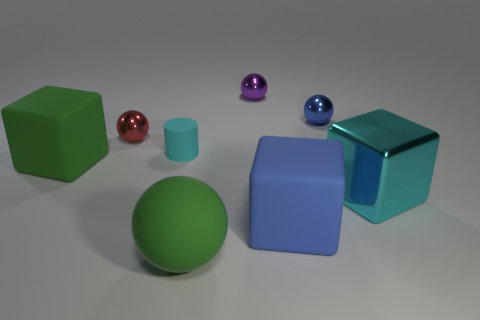What is the shape of the large green object that is behind the large metallic object?
Give a very brief answer. Cube. How many tiny cyan rubber cylinders are left of the green rubber thing that is in front of the cyan cube to the right of the blue metallic object?
Make the answer very short. 1. There is a big rubber block that is behind the blue rubber thing; does it have the same color as the large sphere?
Keep it short and to the point. Yes. What number of other objects are the same shape as the cyan rubber thing?
Provide a short and direct response. 0. What material is the cyan object on the left side of the large green matte thing in front of the blue thing in front of the small red metallic sphere?
Provide a short and direct response. Rubber. Does the blue sphere have the same material as the purple thing?
Your response must be concise. Yes. What number of blocks are either cyan matte things or blue shiny things?
Provide a short and direct response. 0. There is a large object on the left side of the red metallic sphere; what color is it?
Ensure brevity in your answer.  Green. What number of matte objects are small cyan cylinders or red spheres?
Give a very brief answer. 1. There is a sphere that is in front of the matte cube right of the purple metallic ball; what is its material?
Provide a short and direct response. Rubber. 